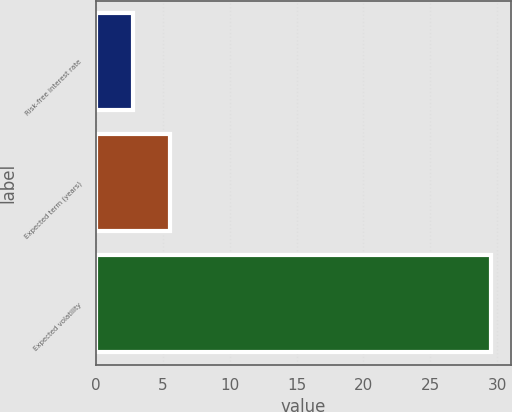Convert chart. <chart><loc_0><loc_0><loc_500><loc_500><bar_chart><fcel>Risk-free interest rate<fcel>Expected term (years)<fcel>Expected volatility<nl><fcel>2.74<fcel>5.5<fcel>29.57<nl></chart> 